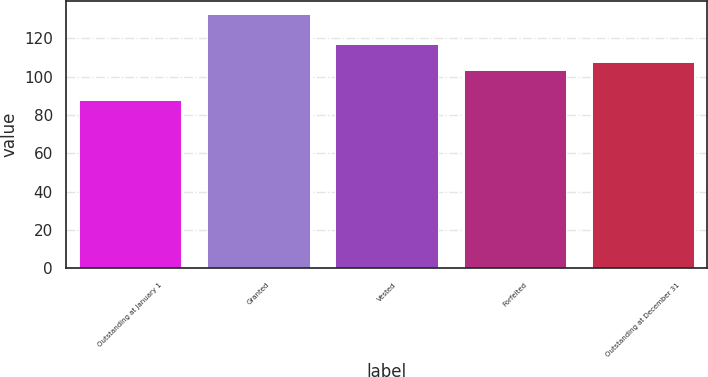Convert chart to OTSL. <chart><loc_0><loc_0><loc_500><loc_500><bar_chart><fcel>Outstanding at January 1<fcel>Granted<fcel>Vested<fcel>Forfeited<fcel>Outstanding at December 31<nl><fcel>87.86<fcel>132.95<fcel>116.83<fcel>103.29<fcel>107.8<nl></chart> 